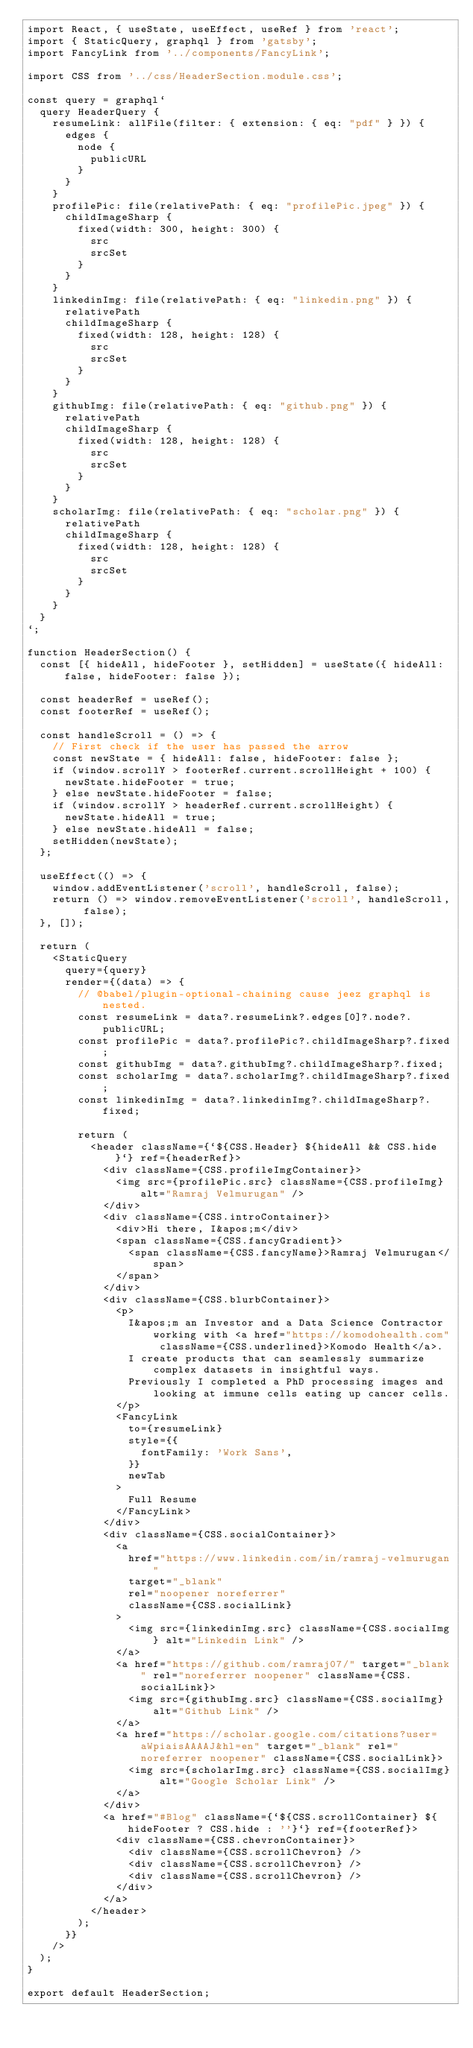<code> <loc_0><loc_0><loc_500><loc_500><_JavaScript_>import React, { useState, useEffect, useRef } from 'react';
import { StaticQuery, graphql } from 'gatsby';
import FancyLink from '../components/FancyLink';

import CSS from '../css/HeaderSection.module.css';

const query = graphql`
  query HeaderQuery {
    resumeLink: allFile(filter: { extension: { eq: "pdf" } }) {
      edges {
        node {
          publicURL
        }
      }
    }
    profilePic: file(relativePath: { eq: "profilePic.jpeg" }) {
      childImageSharp {
        fixed(width: 300, height: 300) {
          src
          srcSet
        }
      }
    }
    linkedinImg: file(relativePath: { eq: "linkedin.png" }) {
      relativePath
      childImageSharp {
        fixed(width: 128, height: 128) {
          src
          srcSet
        }
      }
    }
    githubImg: file(relativePath: { eq: "github.png" }) {
      relativePath
      childImageSharp {
        fixed(width: 128, height: 128) {
          src
          srcSet
        }
      }
    }
    scholarImg: file(relativePath: { eq: "scholar.png" }) {
      relativePath
      childImageSharp {
        fixed(width: 128, height: 128) {
          src
          srcSet
        }
      }
    }
  }
`;

function HeaderSection() {
  const [{ hideAll, hideFooter }, setHidden] = useState({ hideAll: false, hideFooter: false });

  const headerRef = useRef();
  const footerRef = useRef();

  const handleScroll = () => {
    // First check if the user has passed the arrow
    const newState = { hideAll: false, hideFooter: false };
    if (window.scrollY > footerRef.current.scrollHeight + 100) {
      newState.hideFooter = true;
    } else newState.hideFooter = false;
    if (window.scrollY > headerRef.current.scrollHeight) {
      newState.hideAll = true;
    } else newState.hideAll = false;
    setHidden(newState);
  };

  useEffect(() => {
    window.addEventListener('scroll', handleScroll, false);
    return () => window.removeEventListener('scroll', handleScroll, false);
  }, []);

  return (
    <StaticQuery
      query={query}
      render={(data) => {
        // @babel/plugin-optional-chaining cause jeez graphql is nested.
        const resumeLink = data?.resumeLink?.edges[0]?.node?.publicURL;
        const profilePic = data?.profilePic?.childImageSharp?.fixed;
        const githubImg = data?.githubImg?.childImageSharp?.fixed;
        const scholarImg = data?.scholarImg?.childImageSharp?.fixed;
        const linkedinImg = data?.linkedinImg?.childImageSharp?.fixed;

        return (
          <header className={`${CSS.Header} ${hideAll && CSS.hide}`} ref={headerRef}>
            <div className={CSS.profileImgContainer}>
              <img src={profilePic.src} className={CSS.profileImg} alt="Ramraj Velmurugan" />
            </div>
            <div className={CSS.introContainer}>
              <div>Hi there, I&apos;m</div>
              <span className={CSS.fancyGradient}>
                <span className={CSS.fancyName}>Ramraj Velmurugan</span>
              </span>
            </div>
            <div className={CSS.blurbContainer}>
              <p>
                I&apos;m an Investor and a Data Science Contractor working with <a href="https://komodohealth.com" className={CSS.underlined}>Komodo Health</a>.
                I create products that can seamlessly summarize complex datasets in insightful ways. 
                Previously I completed a PhD processing images and looking at immune cells eating up cancer cells.
              </p>
              <FancyLink
                to={resumeLink}
                style={{
                  fontFamily: 'Work Sans',
                }}
                newTab
              >
                Full Resume
              </FancyLink>
            </div>
            <div className={CSS.socialContainer}>
              <a
                href="https://www.linkedin.com/in/ramraj-velmurugan"
                target="_blank"
                rel="noopener noreferrer"
                className={CSS.socialLink}
              >
                <img src={linkedinImg.src} className={CSS.socialImg} alt="Linkedin Link" />
              </a>
              <a href="https://github.com/ramraj07/" target="_blank" rel="noreferrer noopener" className={CSS.socialLink}>
                <img src={githubImg.src} className={CSS.socialImg} alt="Github Link" />
              </a>
              <a href="https://scholar.google.com/citations?user=aWpiaisAAAAJ&hl=en" target="_blank" rel="noreferrer noopener" className={CSS.socialLink}>
                <img src={scholarImg.src} className={CSS.socialImg} alt="Google Scholar Link" />
              </a>
            </div>
            <a href="#Blog" className={`${CSS.scrollContainer} ${hideFooter ? CSS.hide : ''}`} ref={footerRef}>
              <div className={CSS.chevronContainer}>
                <div className={CSS.scrollChevron} />
                <div className={CSS.scrollChevron} />
                <div className={CSS.scrollChevron} />
              </div>
            </a>
          </header>
        );
      }}
    />
  );
}

export default HeaderSection;
</code> 